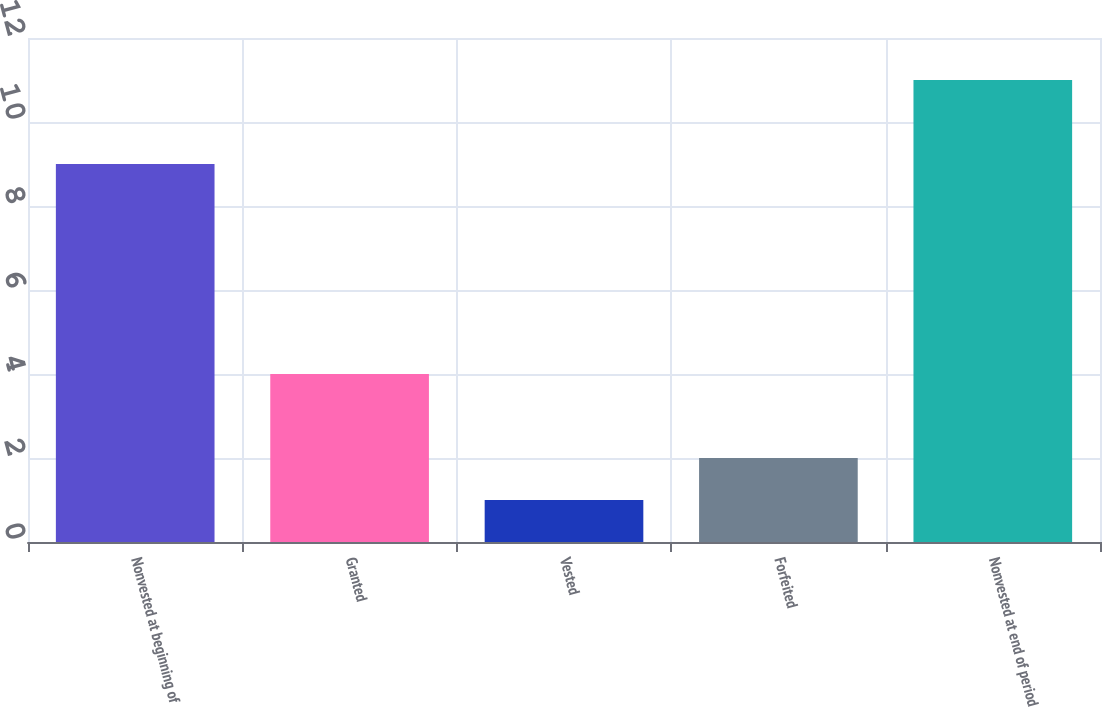Convert chart to OTSL. <chart><loc_0><loc_0><loc_500><loc_500><bar_chart><fcel>Nonvested at beginning of<fcel>Granted<fcel>Vested<fcel>Forfeited<fcel>Nonvested at end of period<nl><fcel>9<fcel>4<fcel>1<fcel>2<fcel>11<nl></chart> 